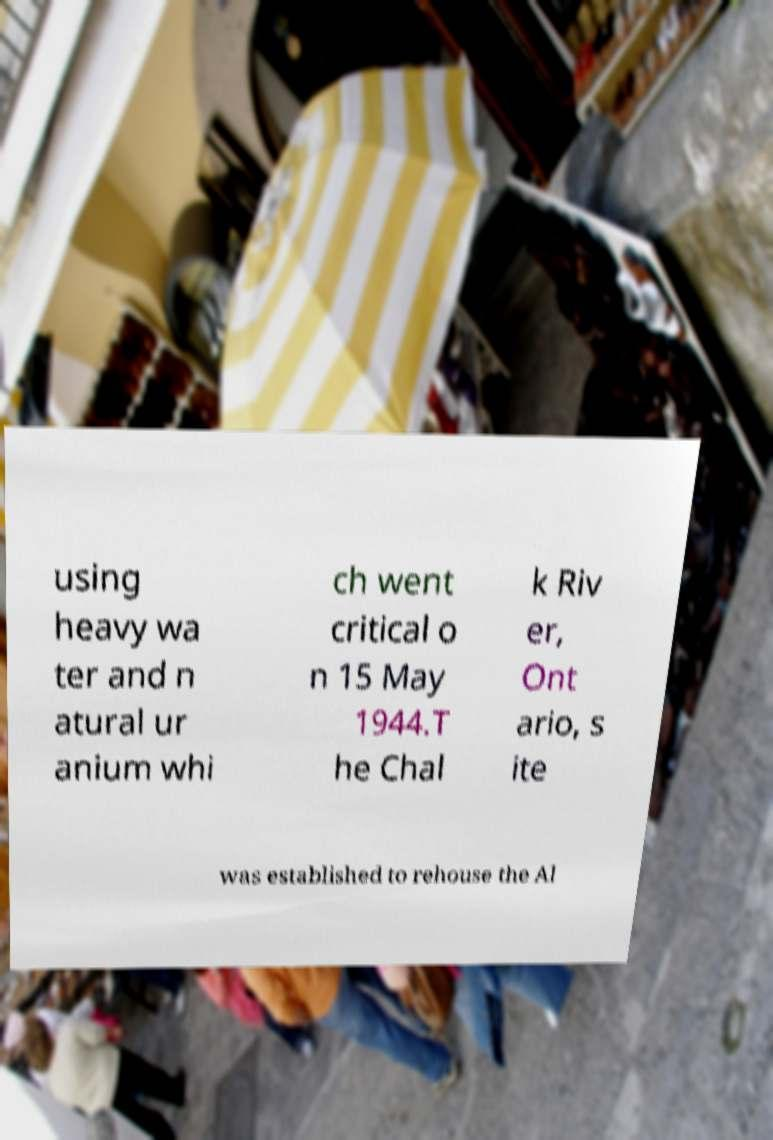Please read and relay the text visible in this image. What does it say? using heavy wa ter and n atural ur anium whi ch went critical o n 15 May 1944.T he Chal k Riv er, Ont ario, s ite was established to rehouse the Al 